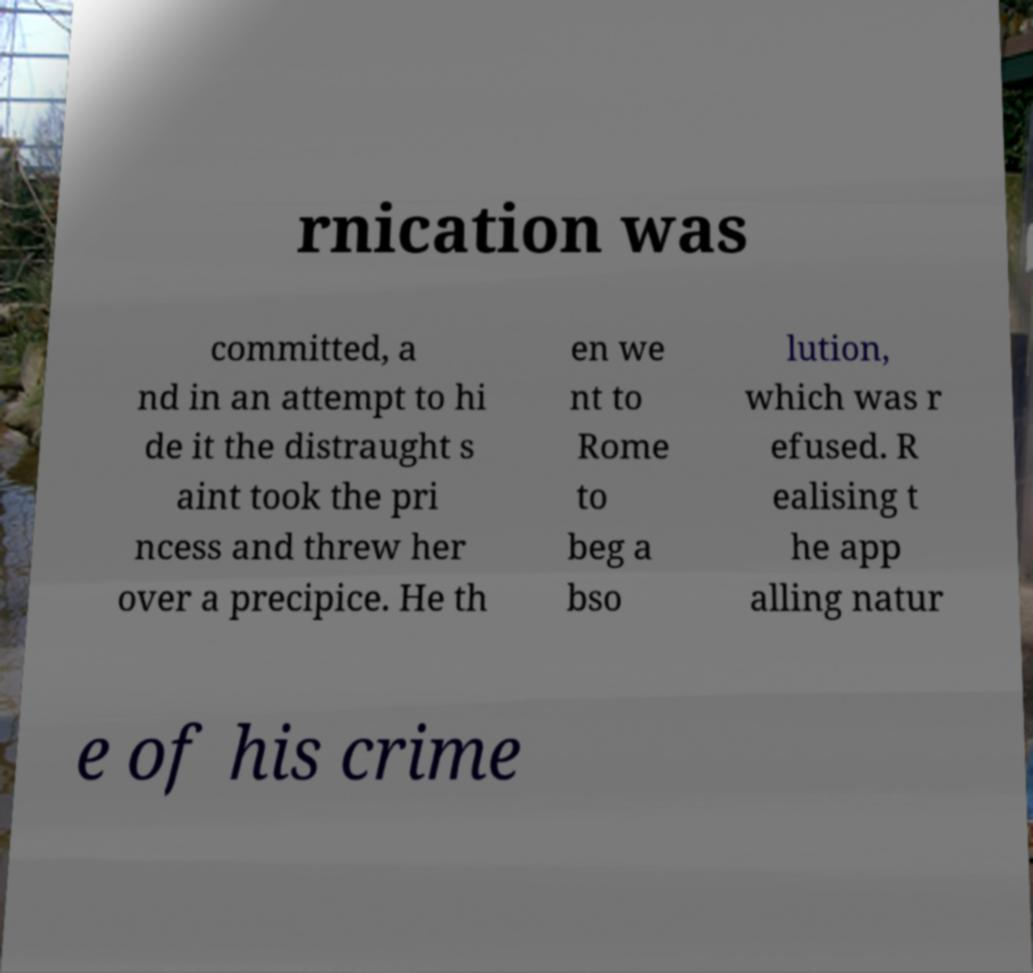I need the written content from this picture converted into text. Can you do that? rnication was committed, a nd in an attempt to hi de it the distraught s aint took the pri ncess and threw her over a precipice. He th en we nt to Rome to beg a bso lution, which was r efused. R ealising t he app alling natur e of his crime 